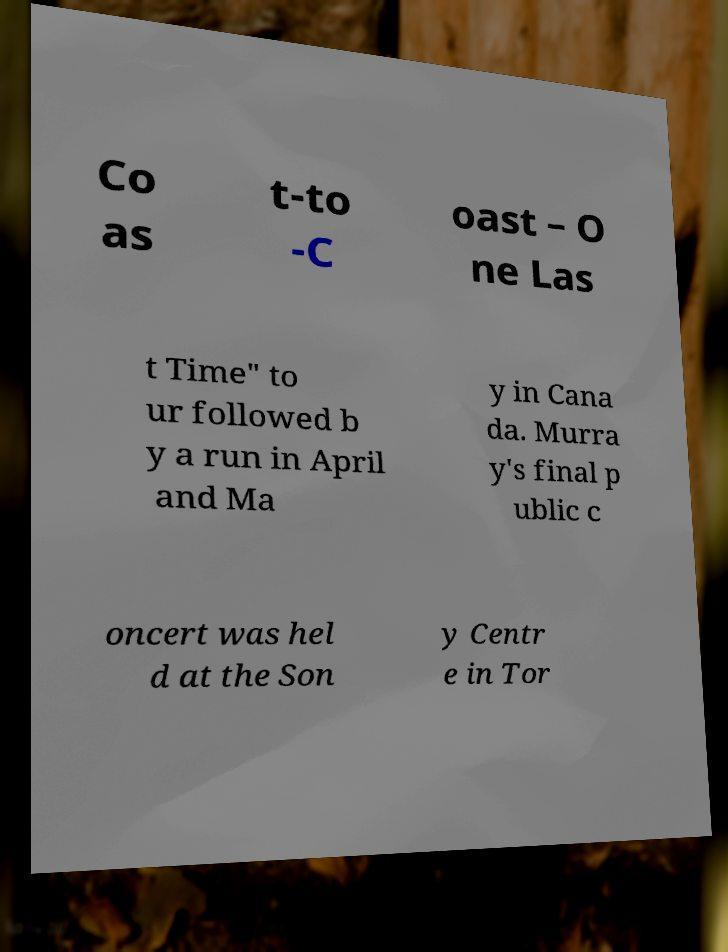There's text embedded in this image that I need extracted. Can you transcribe it verbatim? Co as t-to -C oast – O ne Las t Time" to ur followed b y a run in April and Ma y in Cana da. Murra y's final p ublic c oncert was hel d at the Son y Centr e in Tor 